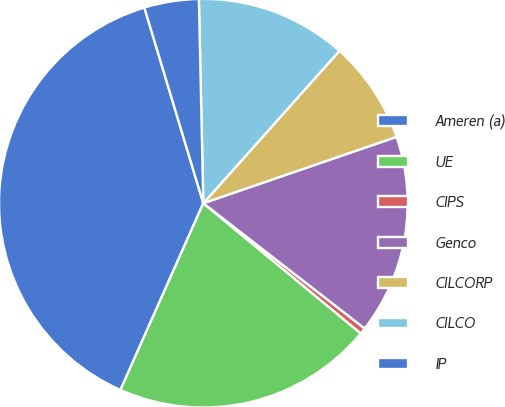Convert chart to OTSL. <chart><loc_0><loc_0><loc_500><loc_500><pie_chart><fcel>Ameren (a)<fcel>UE<fcel>CIPS<fcel>Genco<fcel>CILCORP<fcel>CILCO<fcel>IP<nl><fcel>38.69%<fcel>20.65%<fcel>0.49%<fcel>15.77%<fcel>8.13%<fcel>11.95%<fcel>4.31%<nl></chart> 